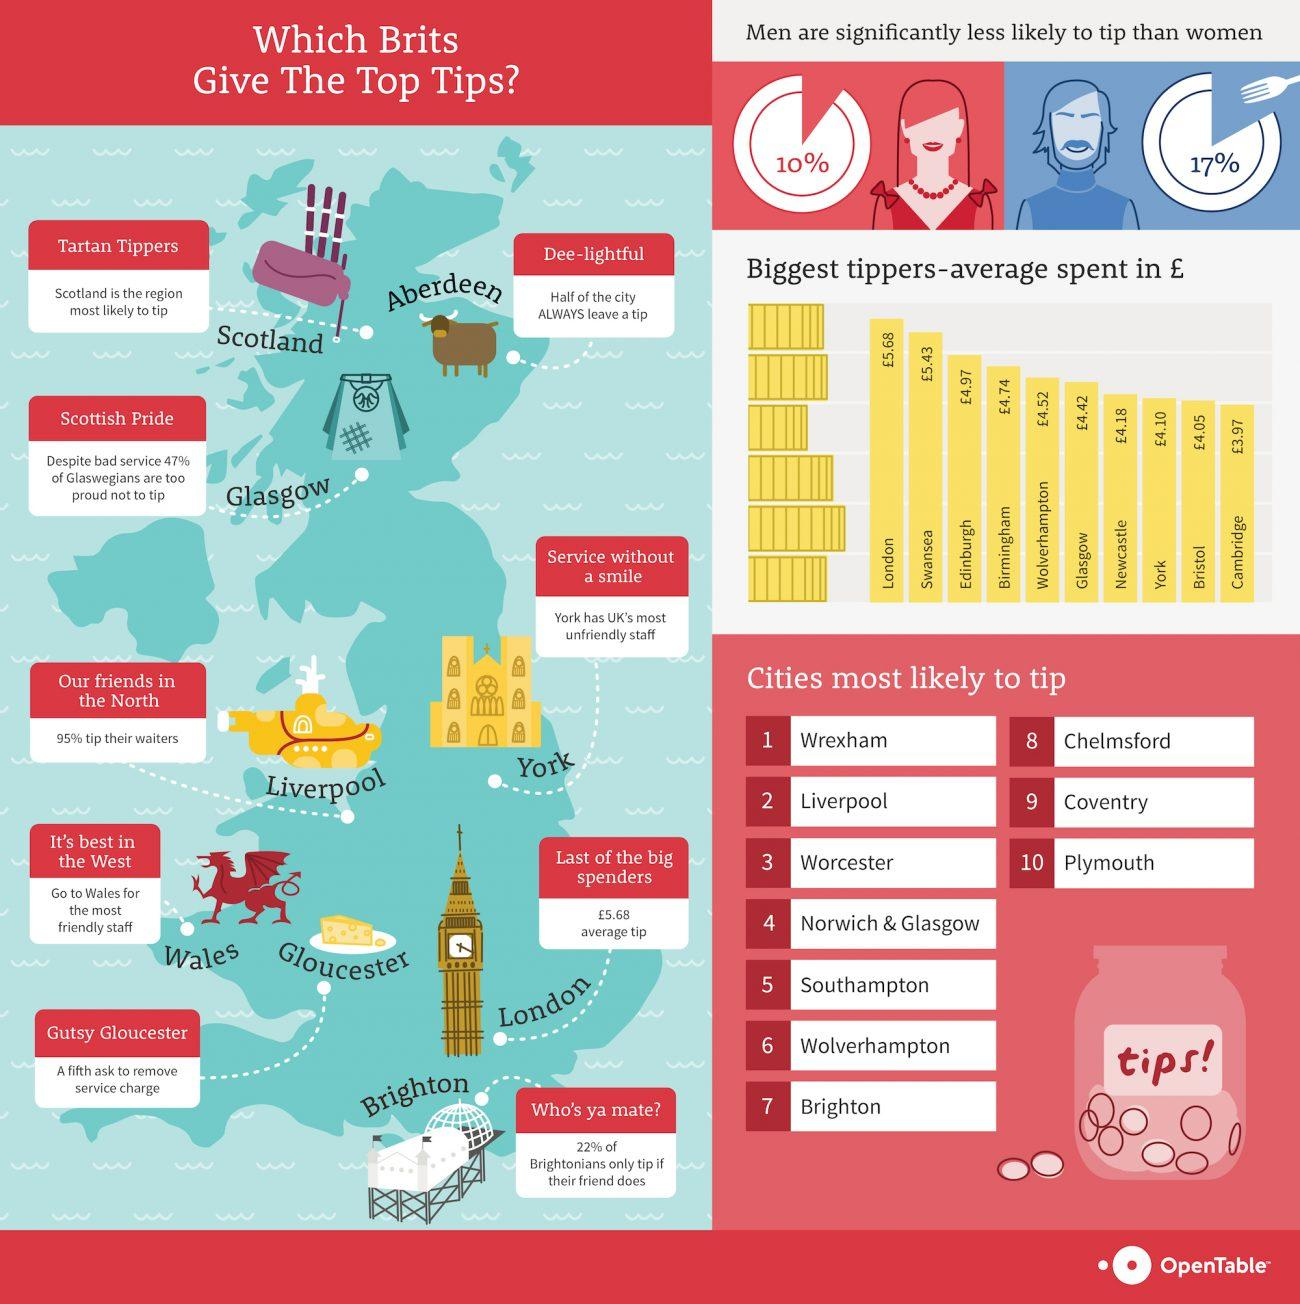Highlight a few significant elements in this photo. According to a recent study, it was found that only 5% of people in Liverpool city do not tip their waiters. The biggest tippers in Cambridge, on average, spend £3.97 in money. The average amount of money spent by the biggest tipper in Bristol is £4.05. The average amount spent by the biggest tippers in London is approximately £5.68. A recent survey in the UK revealed that 17% of tippers are males. 